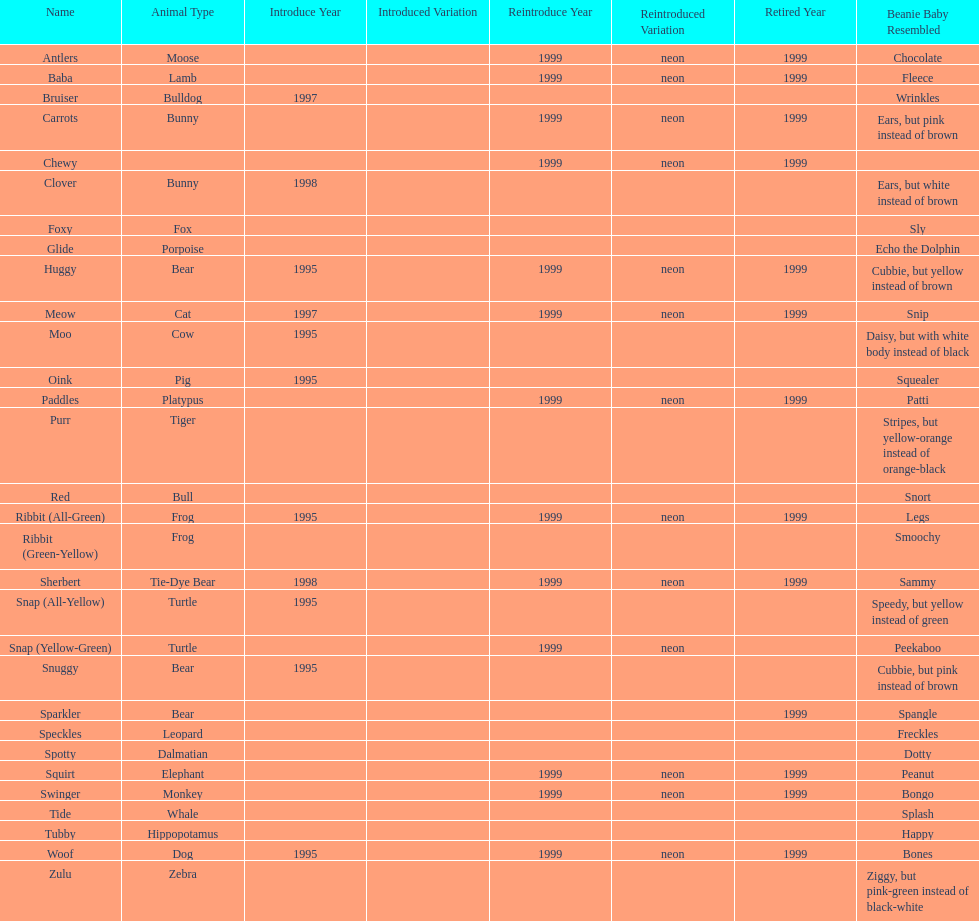How many monkey pillow pals were there? 1. 